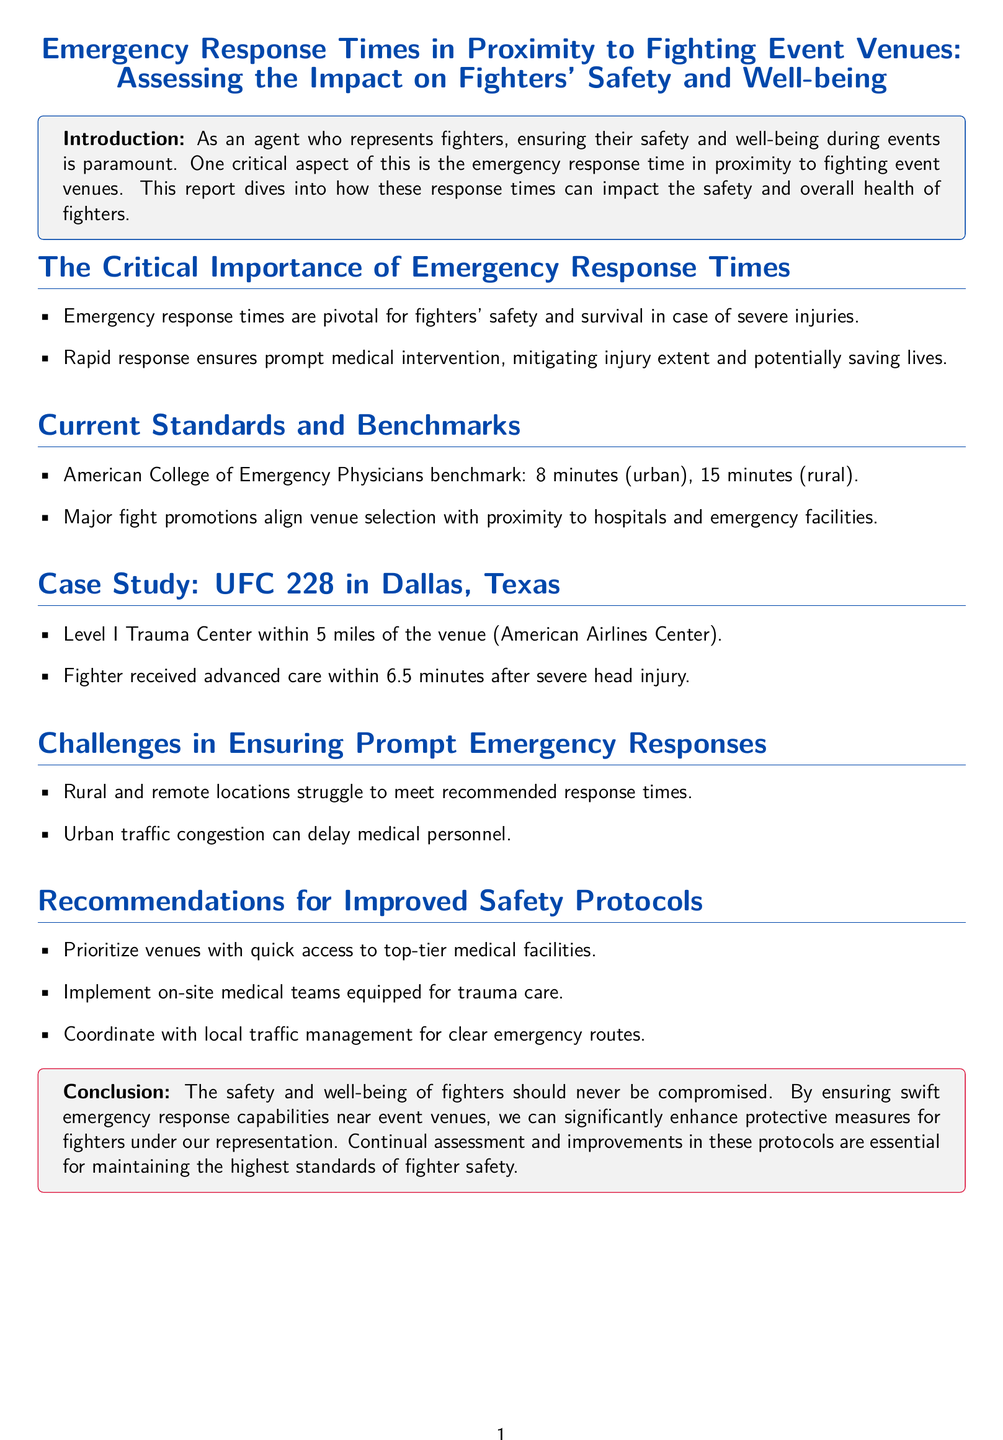What is the benchmark emergency response time in urban areas? The document states that the benchmark emergency response time in urban areas is 8 minutes according to the American College of Emergency Physicians.
Answer: 8 minutes What location is highlighted in the case study? The case study focuses on UFC 228, which took place in Dallas, Texas, specifically at the American Airlines Center.
Answer: Dallas, Texas What is one challenge mentioned regarding emergency response times? The document points out that urban traffic congestion can delay medical personnel as a challenge to ensuring prompt emergency responses.
Answer: Traffic congestion What is the maximum recommended emergency response time for rural areas? According to the document, the maximum recommended emergency response time for rural areas is 15 minutes.
Answer: 15 minutes What type of medical team is recommended to be on-site? The recommendations suggest implementing on-site medical teams that are equipped for trauma care.
Answer: On-site medical teams What significant role does rapid response play in fighter safety? Rapid response ensures prompt medical intervention, which helps in mitigating injury extent and potentially saving lives.
Answer: Mitigating injury extent Which medical facility type was mentioned in the case study? The case study mentions a Level I Trauma Center in proximity to the venue.
Answer: Level I Trauma Center What is the primary purpose of the report? The primary purpose is to assess the impact of emergency response times on fighters' safety and well-being.
Answer: Fighters' safety and well-being 